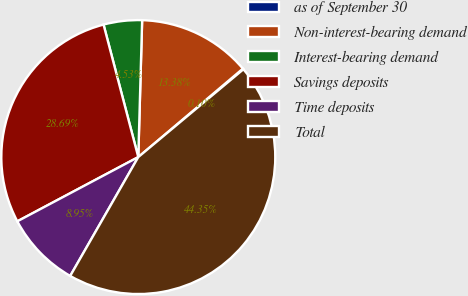Convert chart. <chart><loc_0><loc_0><loc_500><loc_500><pie_chart><fcel>as of September 30<fcel>Non-interest-bearing demand<fcel>Interest-bearing demand<fcel>Savings deposits<fcel>Time deposits<fcel>Total<nl><fcel>0.1%<fcel>13.38%<fcel>4.53%<fcel>28.69%<fcel>8.95%<fcel>44.35%<nl></chart> 